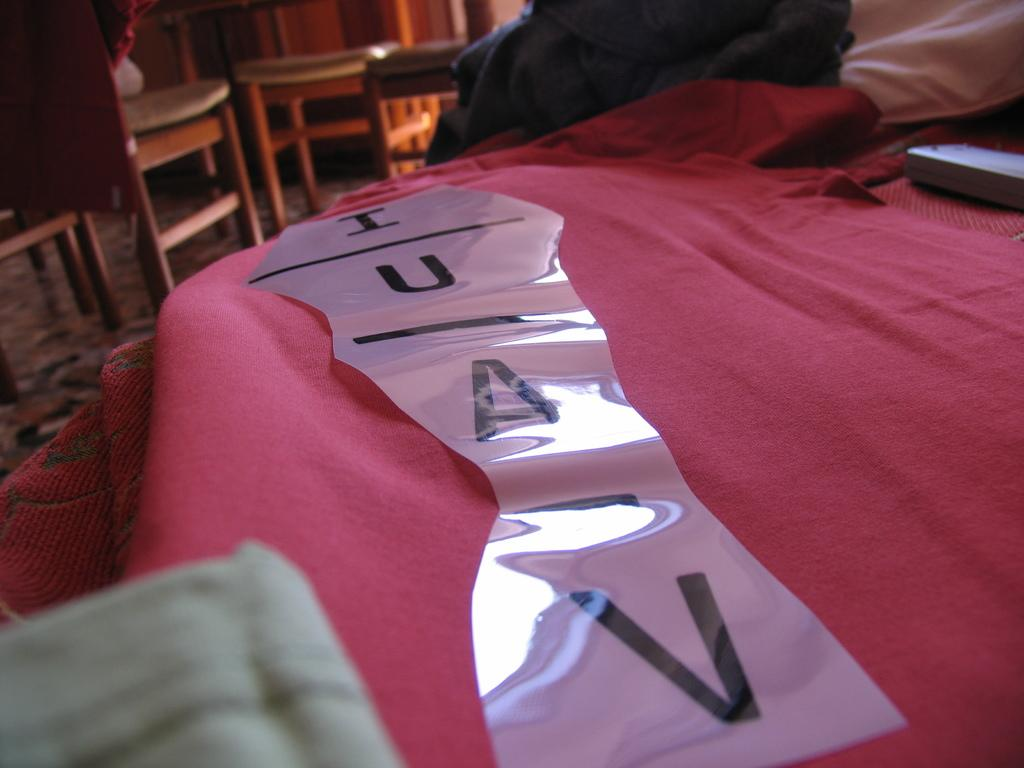What color is the cloth that is visible in the image? There is a red color cloth in the image. What is placed on the red cloth? There is an object on the red cloth. What can be seen in the background of the image? There are chairs and other objects on the floor in the background of the image. How many ants are crawling on the red cloth in the image? There is no mention of ants in the image, so we cannot determine the number of ants. 